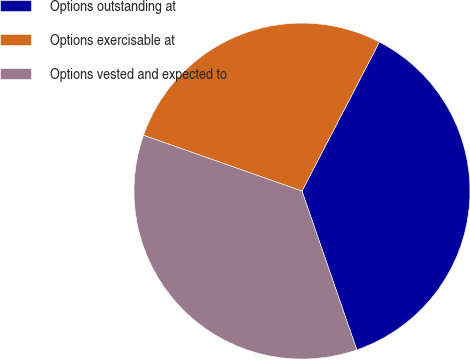<chart> <loc_0><loc_0><loc_500><loc_500><pie_chart><fcel>Options outstanding at<fcel>Options exercisable at<fcel>Options vested and expected to<nl><fcel>37.09%<fcel>27.23%<fcel>35.68%<nl></chart> 